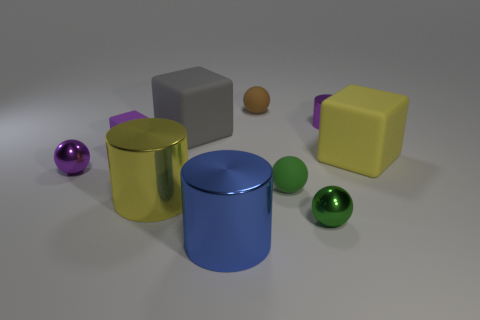Subtract all red balls. Subtract all blue blocks. How many balls are left? 4 Subtract all spheres. How many objects are left? 6 Add 9 purple spheres. How many purple spheres are left? 10 Add 4 large brown spheres. How many large brown spheres exist? 4 Subtract 1 purple balls. How many objects are left? 9 Subtract all blue cylinders. Subtract all matte things. How many objects are left? 4 